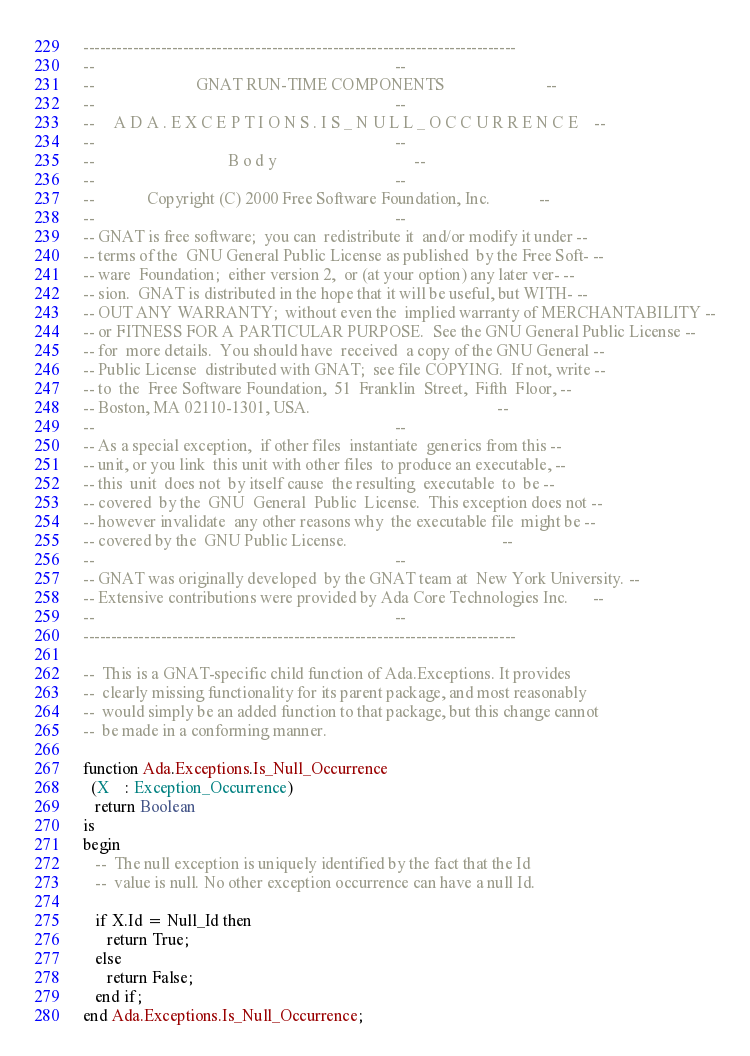Convert code to text. <code><loc_0><loc_0><loc_500><loc_500><_Ada_>------------------------------------------------------------------------------
--                                                                          --
--                         GNAT RUN-TIME COMPONENTS                         --
--                                                                          --
--     A D A . E X C E P T I O N S . I S _ N U L L _ O C C U R R E N C E    --
--                                                                          --
--                                 B o d y                                  --
--                                                                          --
--             Copyright (C) 2000 Free Software Foundation, Inc.            --
--                                                                          --
-- GNAT is free software;  you can  redistribute it  and/or modify it under --
-- terms of the  GNU General Public License as published  by the Free Soft- --
-- ware  Foundation;  either version 2,  or (at your option) any later ver- --
-- sion.  GNAT is distributed in the hope that it will be useful, but WITH- --
-- OUT ANY WARRANTY;  without even the  implied warranty of MERCHANTABILITY --
-- or FITNESS FOR A PARTICULAR PURPOSE.  See the GNU General Public License --
-- for  more details.  You should have  received  a copy of the GNU General --
-- Public License  distributed with GNAT;  see file COPYING.  If not, write --
-- to  the  Free Software Foundation,  51  Franklin  Street,  Fifth  Floor, --
-- Boston, MA 02110-1301, USA.                                              --
--                                                                          --
-- As a special exception,  if other files  instantiate  generics from this --
-- unit, or you link  this unit with other files  to produce an executable, --
-- this  unit  does not  by itself cause  the resulting  executable  to  be --
-- covered  by the  GNU  General  Public  License.  This exception does not --
-- however invalidate  any other reasons why  the executable file  might be --
-- covered by the  GNU Public License.                                      --
--                                                                          --
-- GNAT was originally developed  by the GNAT team at  New York University. --
-- Extensive contributions were provided by Ada Core Technologies Inc.      --
--                                                                          --
------------------------------------------------------------------------------

--  This is a GNAT-specific child function of Ada.Exceptions. It provides
--  clearly missing functionality for its parent package, and most reasonably
--  would simply be an added function to that package, but this change cannot
--  be made in a conforming manner.

function Ada.Exceptions.Is_Null_Occurrence
  (X    : Exception_Occurrence)
   return Boolean
is
begin
   --  The null exception is uniquely identified by the fact that the Id
   --  value is null. No other exception occurrence can have a null Id.

   if X.Id = Null_Id then
      return True;
   else
      return False;
   end if;
end Ada.Exceptions.Is_Null_Occurrence;
</code> 